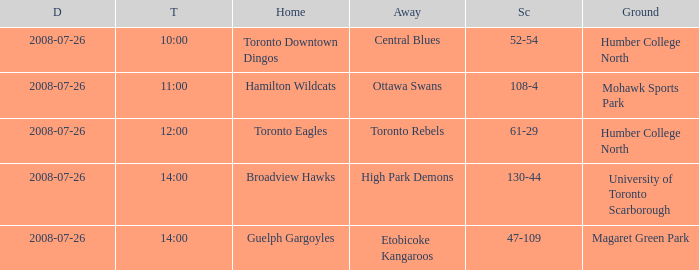With the Ground of Humber College North at 12:00, what was the Away? Toronto Rebels. 